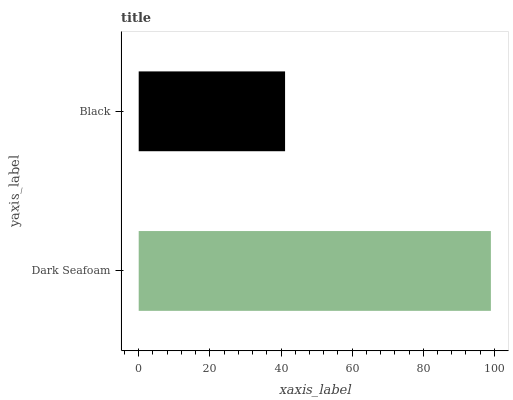Is Black the minimum?
Answer yes or no. Yes. Is Dark Seafoam the maximum?
Answer yes or no. Yes. Is Black the maximum?
Answer yes or no. No. Is Dark Seafoam greater than Black?
Answer yes or no. Yes. Is Black less than Dark Seafoam?
Answer yes or no. Yes. Is Black greater than Dark Seafoam?
Answer yes or no. No. Is Dark Seafoam less than Black?
Answer yes or no. No. Is Dark Seafoam the high median?
Answer yes or no. Yes. Is Black the low median?
Answer yes or no. Yes. Is Black the high median?
Answer yes or no. No. Is Dark Seafoam the low median?
Answer yes or no. No. 